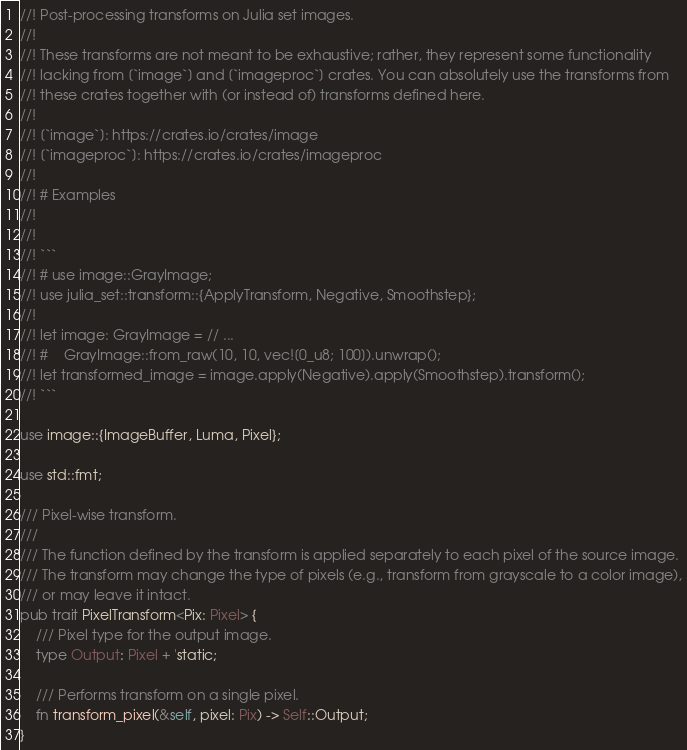<code> <loc_0><loc_0><loc_500><loc_500><_Rust_>//! Post-processing transforms on Julia set images.
//!
//! These transforms are not meant to be exhaustive; rather, they represent some functionality
//! lacking from [`image`] and [`imageproc`] crates. You can absolutely use the transforms from
//! these crates together with (or instead of) transforms defined here.
//!
//! [`image`]: https://crates.io/crates/image
//! [`imageproc`]: https://crates.io/crates/imageproc
//!
//! # Examples
//!
//!
//! ```
//! # use image::GrayImage;
//! use julia_set::transform::{ApplyTransform, Negative, Smoothstep};
//!
//! let image: GrayImage = // ...
//! #    GrayImage::from_raw(10, 10, vec![0_u8; 100]).unwrap();
//! let transformed_image = image.apply(Negative).apply(Smoothstep).transform();
//! ```

use image::{ImageBuffer, Luma, Pixel};

use std::fmt;

/// Pixel-wise transform.
///
/// The function defined by the transform is applied separately to each pixel of the source image.
/// The transform may change the type of pixels (e.g., transform from grayscale to a color image),
/// or may leave it intact.
pub trait PixelTransform<Pix: Pixel> {
    /// Pixel type for the output image.
    type Output: Pixel + 'static;

    /// Performs transform on a single pixel.
    fn transform_pixel(&self, pixel: Pix) -> Self::Output;
}
</code> 